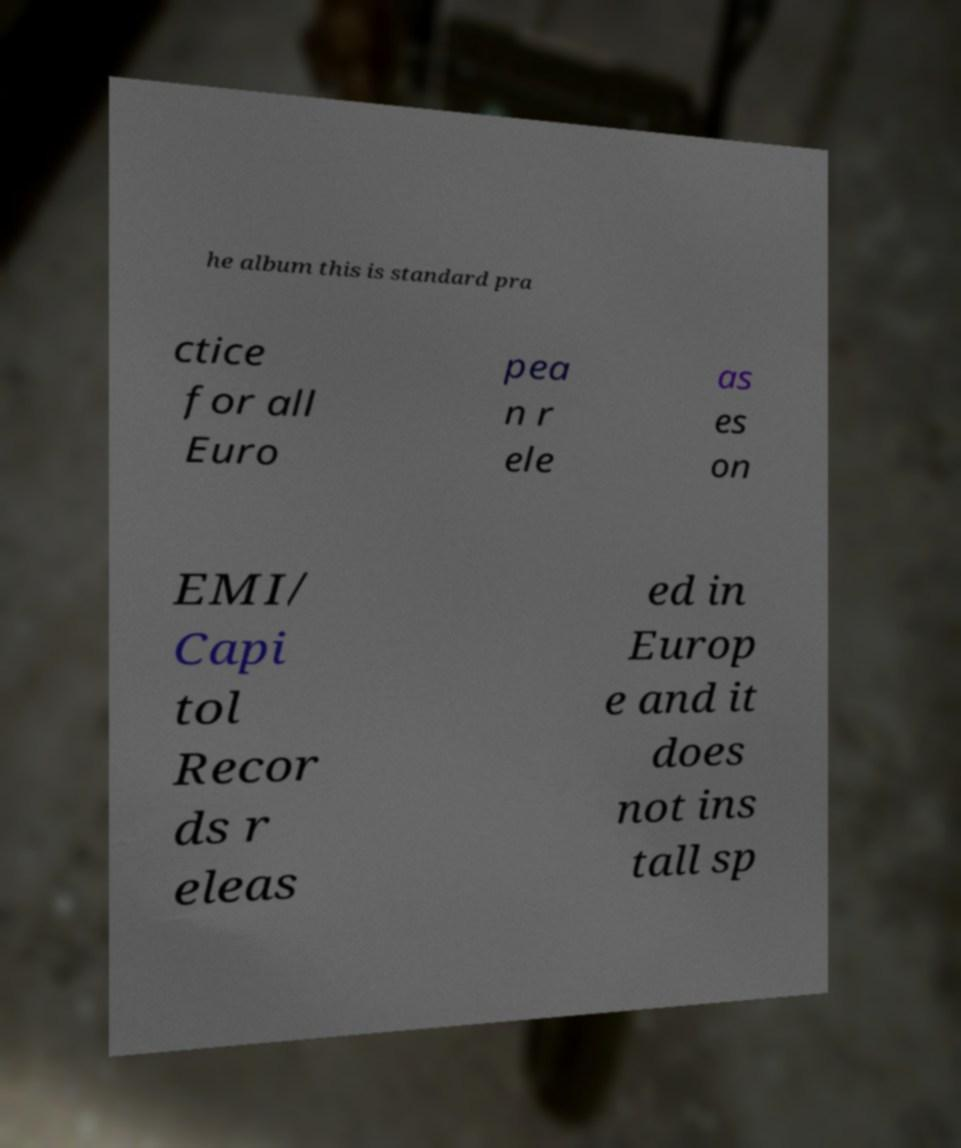Can you accurately transcribe the text from the provided image for me? he album this is standard pra ctice for all Euro pea n r ele as es on EMI/ Capi tol Recor ds r eleas ed in Europ e and it does not ins tall sp 